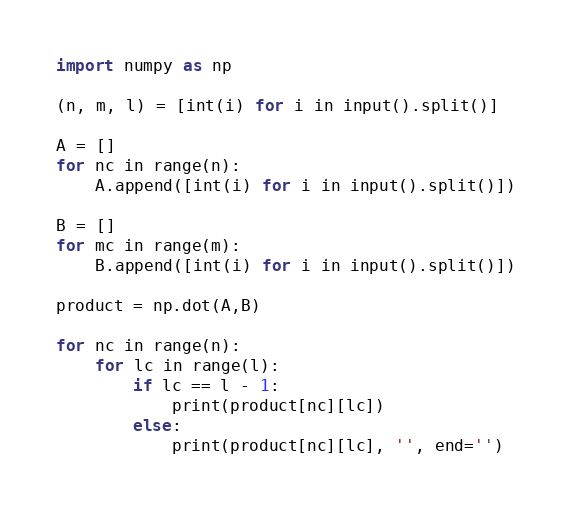<code> <loc_0><loc_0><loc_500><loc_500><_Python_>import numpy as np

(n, m, l) = [int(i) for i in input().split()]

A = []
for nc in range(n):
    A.append([int(i) for i in input().split()])

B = []
for mc in range(m):
    B.append([int(i) for i in input().split()])

product = np.dot(A,B)

for nc in range(n):
    for lc in range(l):
        if lc == l - 1:
            print(product[nc][lc])
        else:
            print(product[nc][lc], '', end='')</code> 